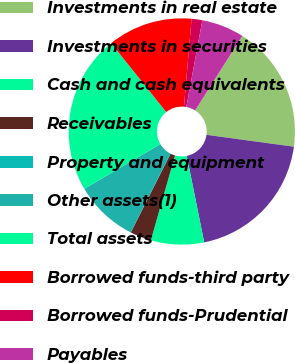Convert chart. <chart><loc_0><loc_0><loc_500><loc_500><pie_chart><fcel>Investments in real estate<fcel>Investments in securities<fcel>Cash and cash equivalents<fcel>Receivables<fcel>Property and equipment<fcel>Other assets(1)<fcel>Total assets<fcel>Borrowed funds-third party<fcel>Borrowed funds-Prudential<fcel>Payables<nl><fcel>18.17%<fcel>19.68%<fcel>7.58%<fcel>3.04%<fcel>0.01%<fcel>9.09%<fcel>22.71%<fcel>12.12%<fcel>1.53%<fcel>6.07%<nl></chart> 